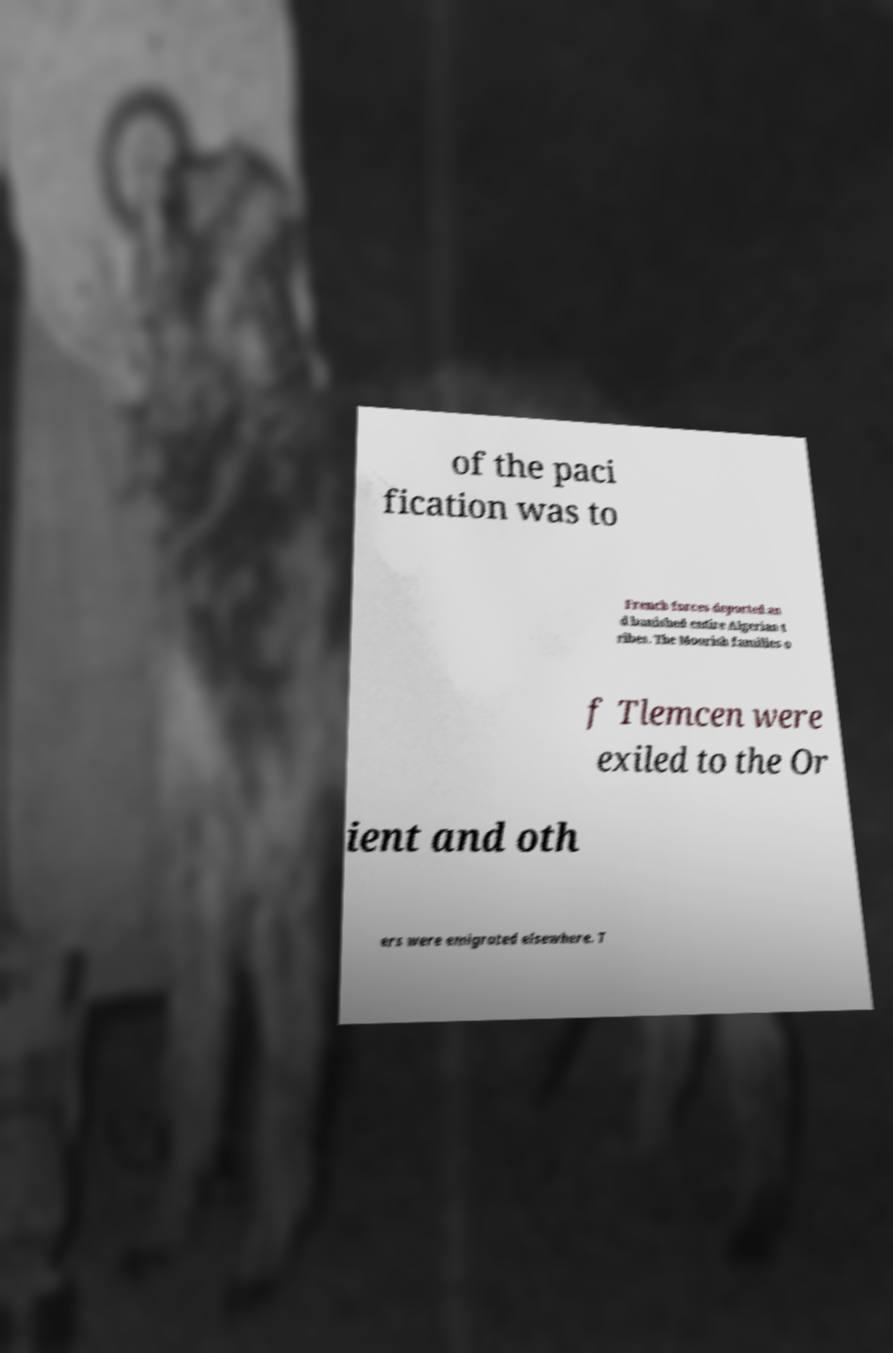Please identify and transcribe the text found in this image. of the paci fication was to French forces deported an d banished entire Algerian t ribes. The Moorish families o f Tlemcen were exiled to the Or ient and oth ers were emigrated elsewhere. T 